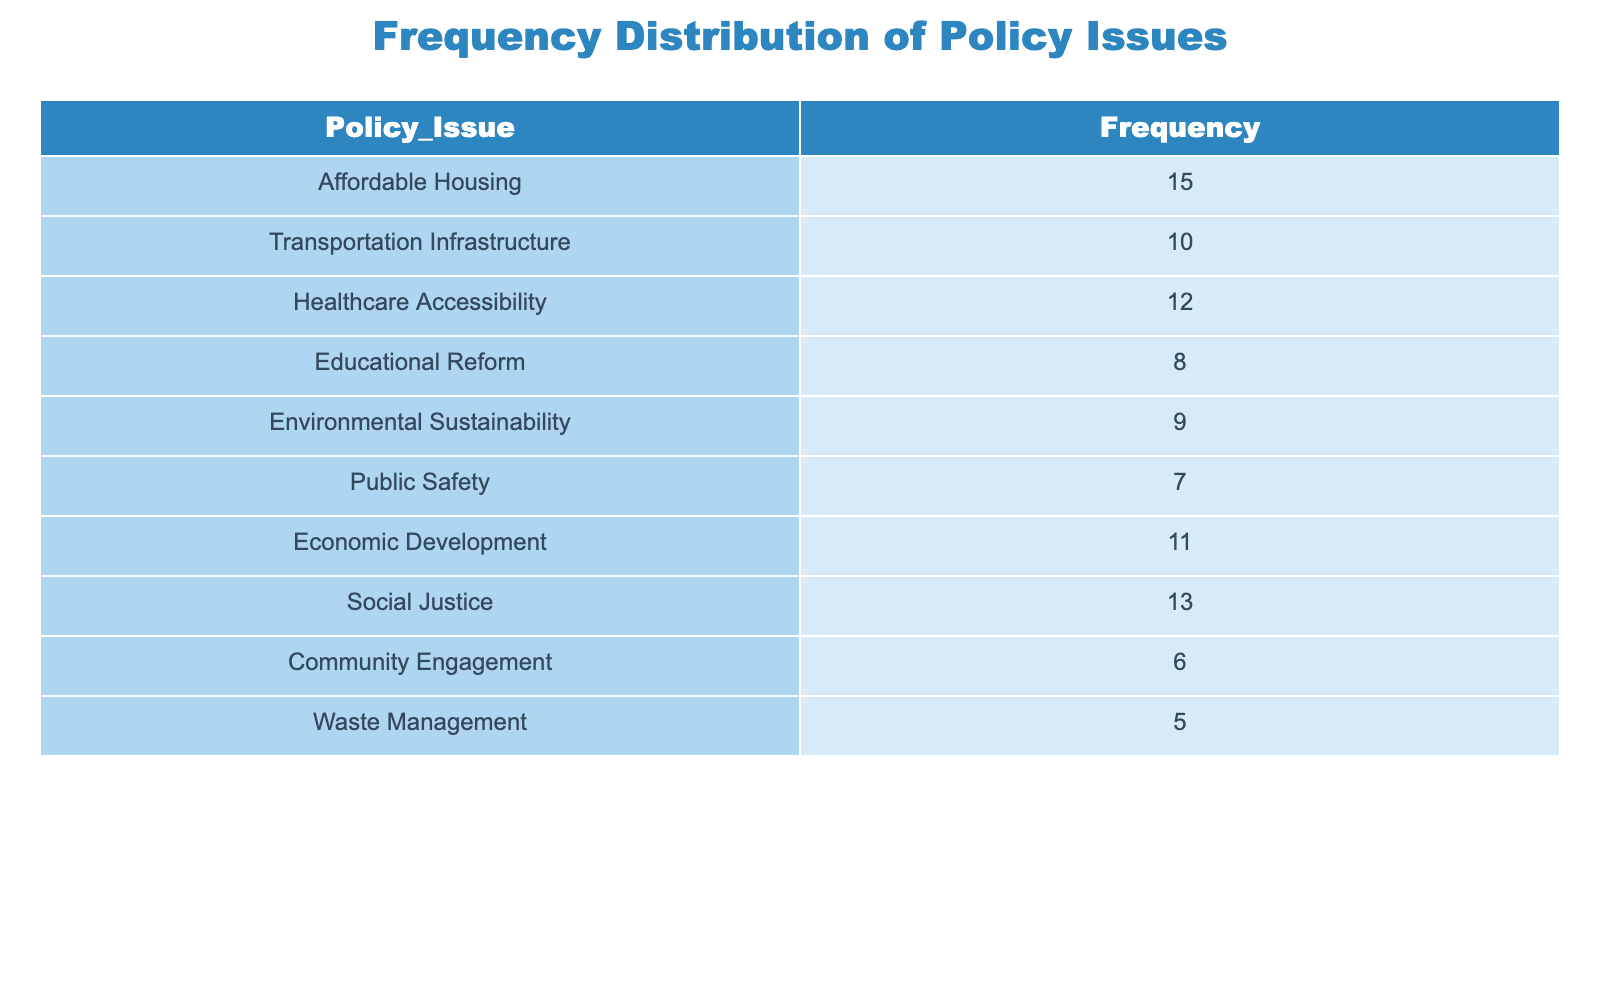What is the most frequently raised policy issue in the community forums? The table shows the frequency of various policy issues. We can see that "Affordable Housing" has the highest frequency at 15, indicating it is the most frequently raised issue.
Answer: Affordable Housing How many policy issues have a frequency greater than 10? By reviewing the frequency values, we identify the issues that exceed 10. These are "Affordable Housing" (15), "Healthcare Accessibility" (12), "Social Justice" (13), and "Economic Development" (11), which totals 4 policy issues.
Answer: 4 What is the total frequency of the policy issues related to community welfare (Affordable Housing, Healthcare Accessibility, and Social Justice)? To find the total frequency of community welfare issues, we sum their frequencies: 15 (Affordable Housing) + 12 (Healthcare Accessibility) + 13 (Social Justice) = 40.
Answer: 40 Is "Public Safety" more frequently raised than "Waste Management"? The frequency of "Public Safety" is 7, while "Waste Management" has a frequency of 5. Since 7 is greater than 5, "Public Safety" is raised more frequently.
Answer: Yes What is the average frequency of the policy issues listed in the table? To calculate the average frequency, we first sum all the frequencies: 15 + 10 + 12 + 8 + 9 + 7 + 11 + 13 + 6 + 5 = 96. There are 10 issues, so we divide: 96 / 10 = 9.6.
Answer: 9.6 Which policy issue has the lowest frequency, and what is that frequency? Upon examining the table, "Waste Management" has the lowest frequency at 5, as it is the issue with the smallest value in the frequency column.
Answer: Waste Management, 5 How many issues are related to social or community welfare based on the given categories? The relevant issues categorized under social/community welfare include "Affordable Housing," "Healthcare Accessibility," "Social Justice," and "Community Engagement." Therefore, there are 4 such issues.
Answer: 4 What is the difference in frequency between "Economic Development" and "Transportation Infrastructure"? The frequency of "Economic Development" is 11, and for "Transportation Infrastructure," it is 10. The difference is 11 - 10 = 1.
Answer: 1 